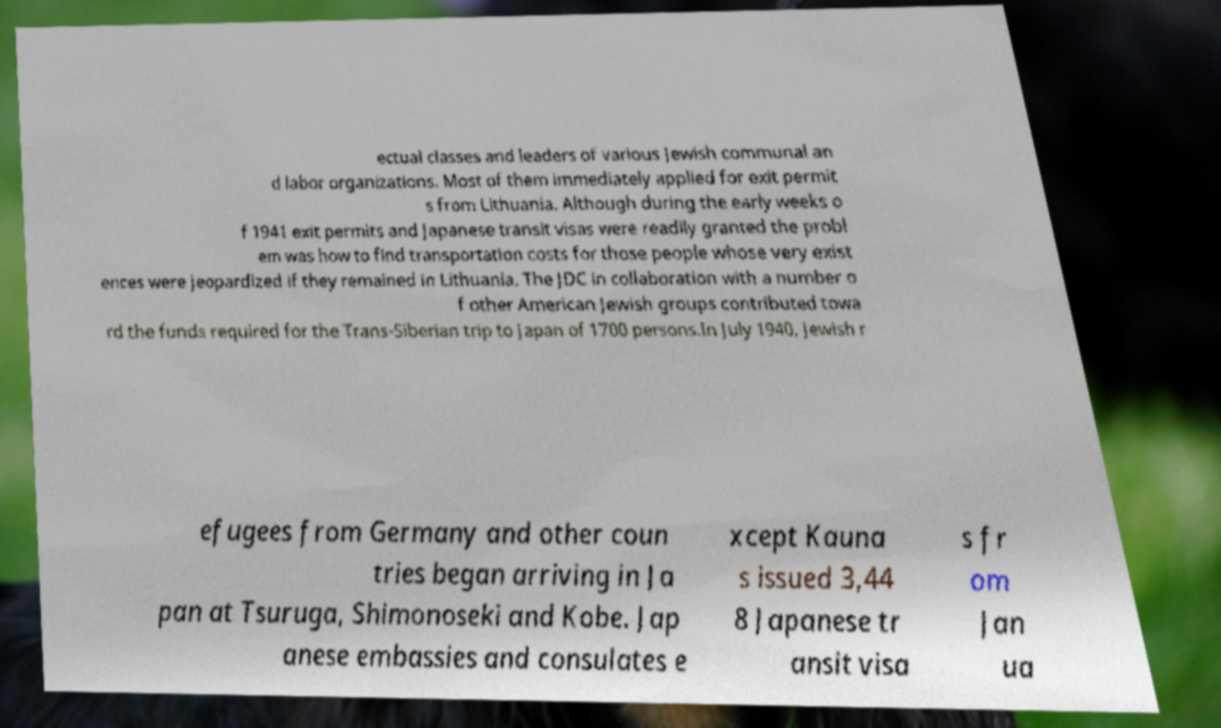Could you extract and type out the text from this image? ectual classes and leaders of various Jewish communal an d labor organizations. Most of them immediately applied for exit permit s from Lithuania. Although during the early weeks o f 1941 exit permits and Japanese transit visas were readily granted the probl em was how to find transportation costs for those people whose very exist ences were jeopardized if they remained in Lithuania. The JDC in collaboration with a number o f other American Jewish groups contributed towa rd the funds required for the Trans-Siberian trip to Japan of 1700 persons.In July 1940, Jewish r efugees from Germany and other coun tries began arriving in Ja pan at Tsuruga, Shimonoseki and Kobe. Jap anese embassies and consulates e xcept Kauna s issued 3,44 8 Japanese tr ansit visa s fr om Jan ua 